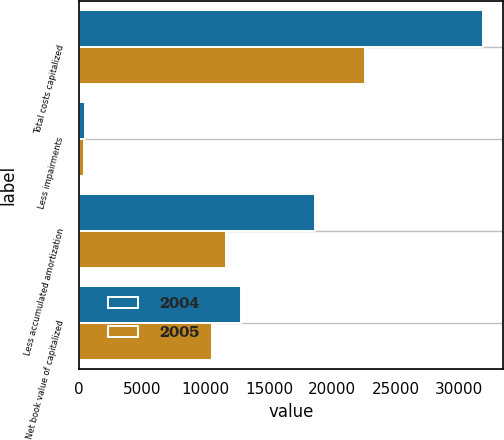Convert chart. <chart><loc_0><loc_0><loc_500><loc_500><stacked_bar_chart><ecel><fcel>Total costs capitalized<fcel>Less impairments<fcel>Less accumulated amortization<fcel>Net book value of capitalized<nl><fcel>2004<fcel>31856<fcel>485<fcel>18598<fcel>12773<nl><fcel>2005<fcel>22604<fcel>446<fcel>11629<fcel>10529<nl></chart> 